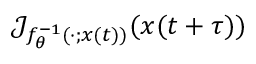<formula> <loc_0><loc_0><loc_500><loc_500>\mathcal { J } _ { f _ { \theta } ^ { - 1 } ; x ( t ) ) } ( x ( t + \tau ) )</formula> 